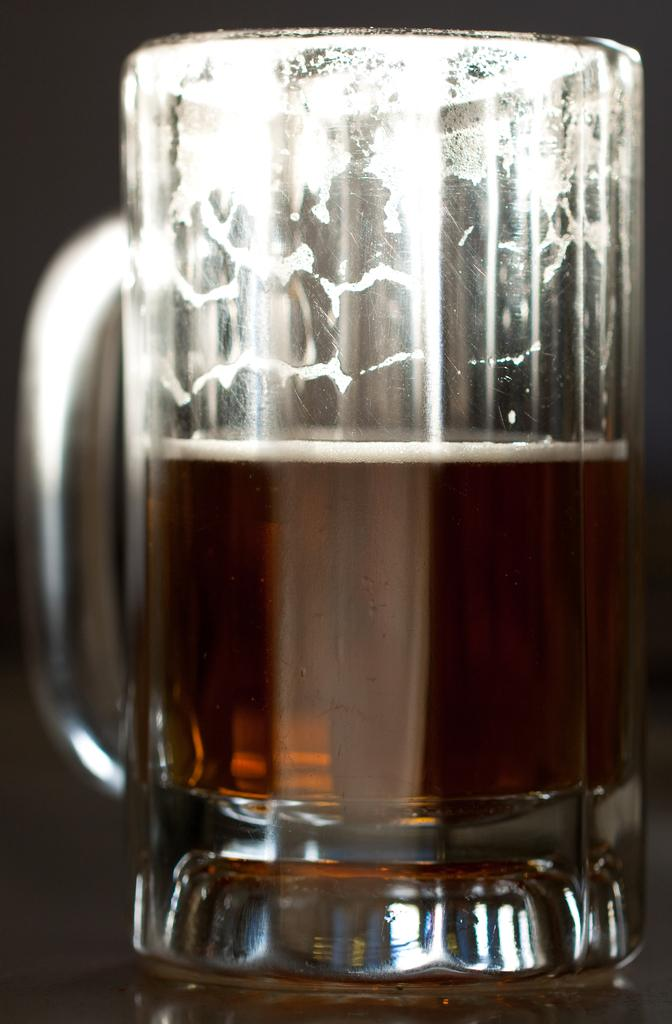What object is present in the image that can hold a liquid? There is a glass in the image. What is inside the glass? The glass contains a drink. What type of trains can be seen passing by in the image? There are no trains present in the image; it only features a glass containing a drink. What color is the dress worn by the person holding the glass in the image? There is no person holding the glass in the image, and therefore no dress to describe. 